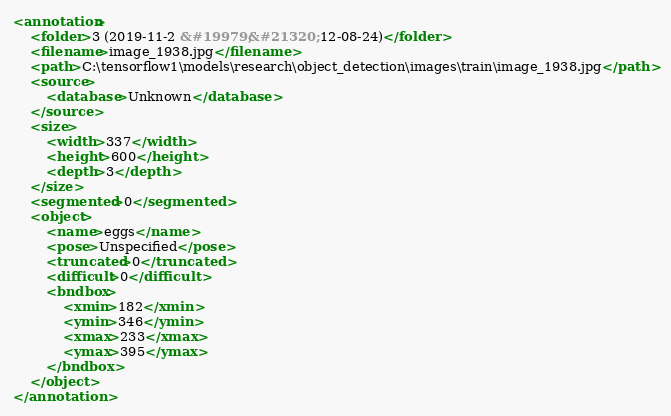Convert code to text. <code><loc_0><loc_0><loc_500><loc_500><_XML_><annotation>
	<folder>3 (2019-11-2 &#19979;&#21320; 12-08-24)</folder>
	<filename>image_1938.jpg</filename>
	<path>C:\tensorflow1\models\research\object_detection\images\train\image_1938.jpg</path>
	<source>
		<database>Unknown</database>
	</source>
	<size>
		<width>337</width>
		<height>600</height>
		<depth>3</depth>
	</size>
	<segmented>0</segmented>
	<object>
		<name>eggs</name>
		<pose>Unspecified</pose>
		<truncated>0</truncated>
		<difficult>0</difficult>
		<bndbox>
			<xmin>182</xmin>
			<ymin>346</ymin>
			<xmax>233</xmax>
			<ymax>395</ymax>
		</bndbox>
	</object>
</annotation></code> 